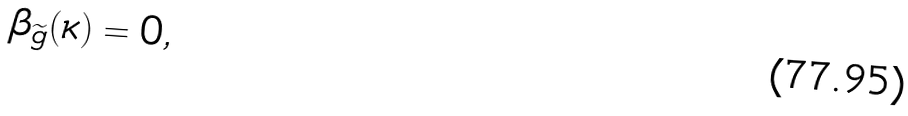<formula> <loc_0><loc_0><loc_500><loc_500>\beta _ { \widetilde { g } } ( \kappa ) = 0 ,</formula> 